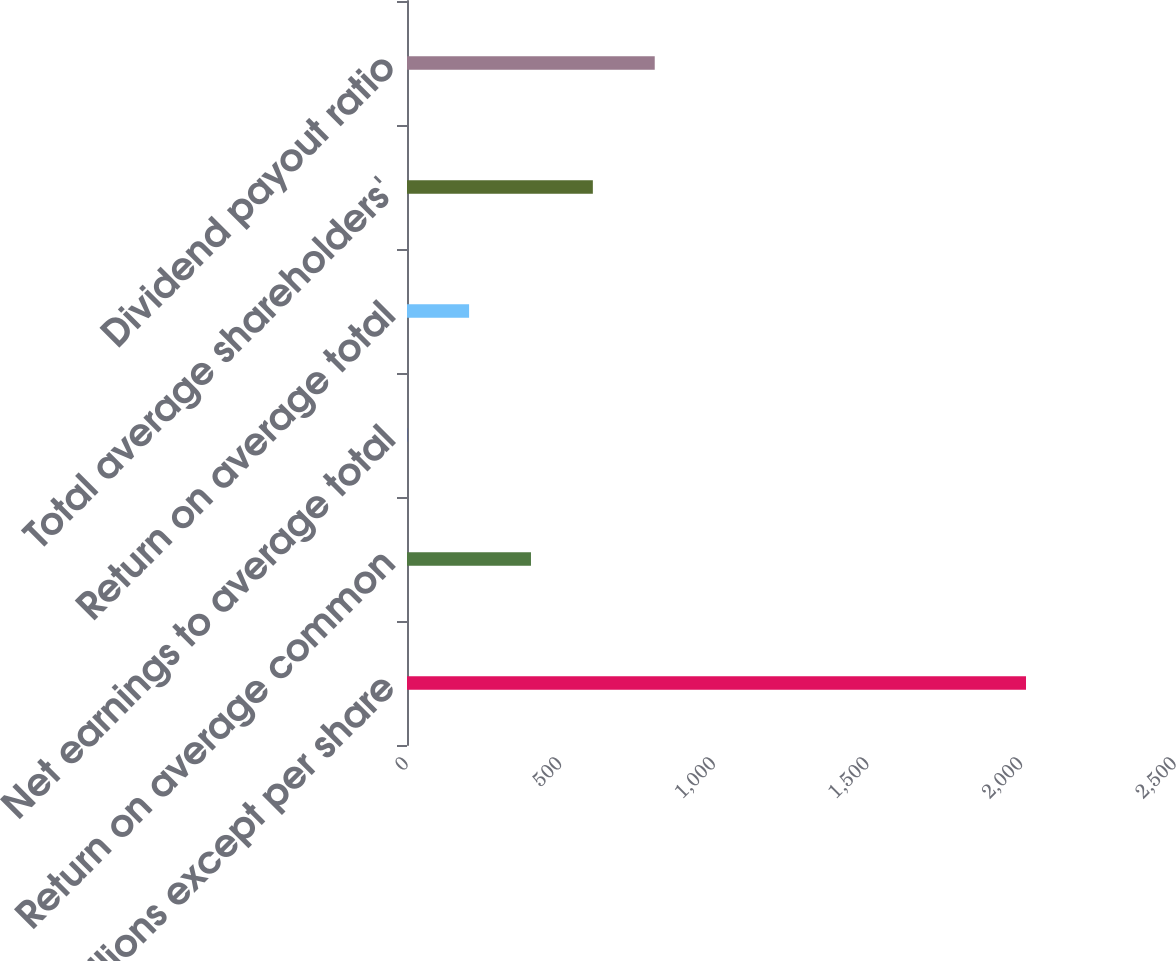Convert chart. <chart><loc_0><loc_0><loc_500><loc_500><bar_chart><fcel>in millions except per share<fcel>Return on average common<fcel>Net earnings to average total<fcel>Return on average total<fcel>Total average shareholders'<fcel>Dividend payout ratio<nl><fcel>2015<fcel>403.56<fcel>0.7<fcel>202.13<fcel>604.99<fcel>806.42<nl></chart> 